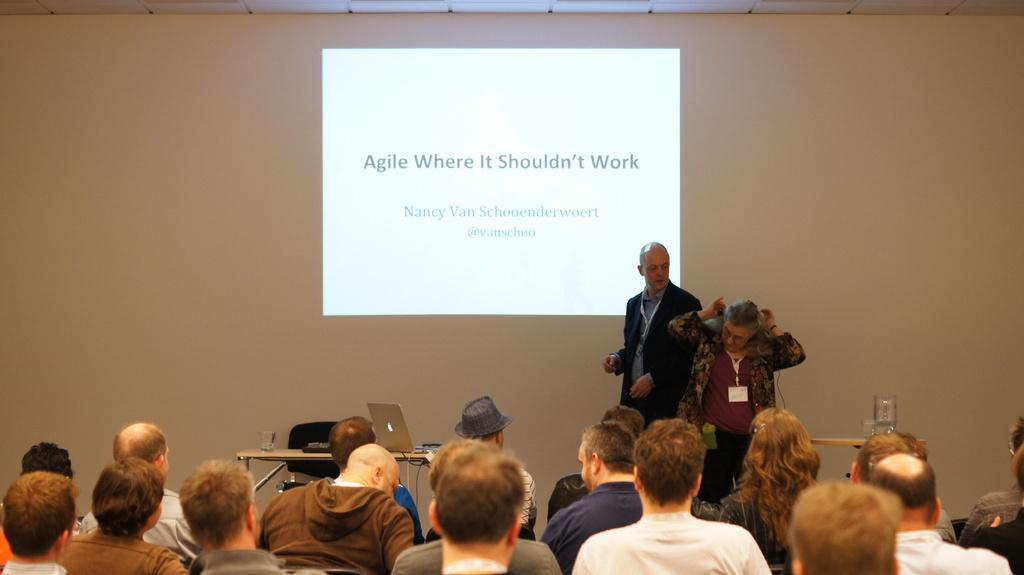How would you summarize this image in a sentence or two? In the picture I can see two persons standing and there is a table beside them which has a laptop and some other objects on it and there are few people sitting in front of them and there is a projected image in the background. 